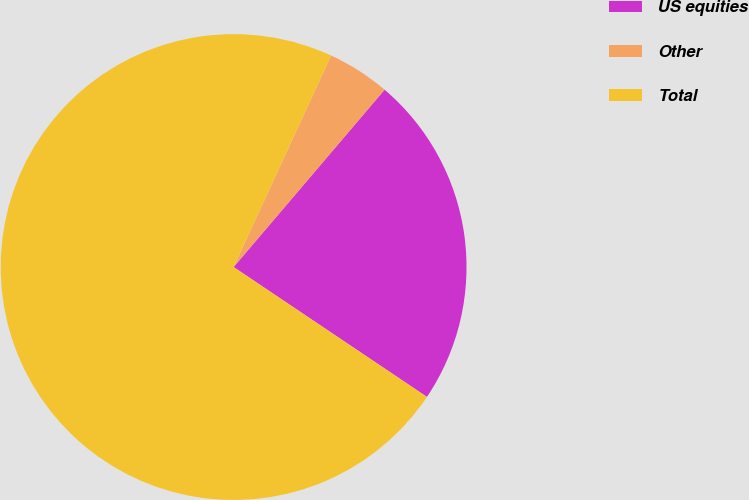Convert chart. <chart><loc_0><loc_0><loc_500><loc_500><pie_chart><fcel>US equities<fcel>Other<fcel>Total<nl><fcel>23.19%<fcel>4.35%<fcel>72.46%<nl></chart> 